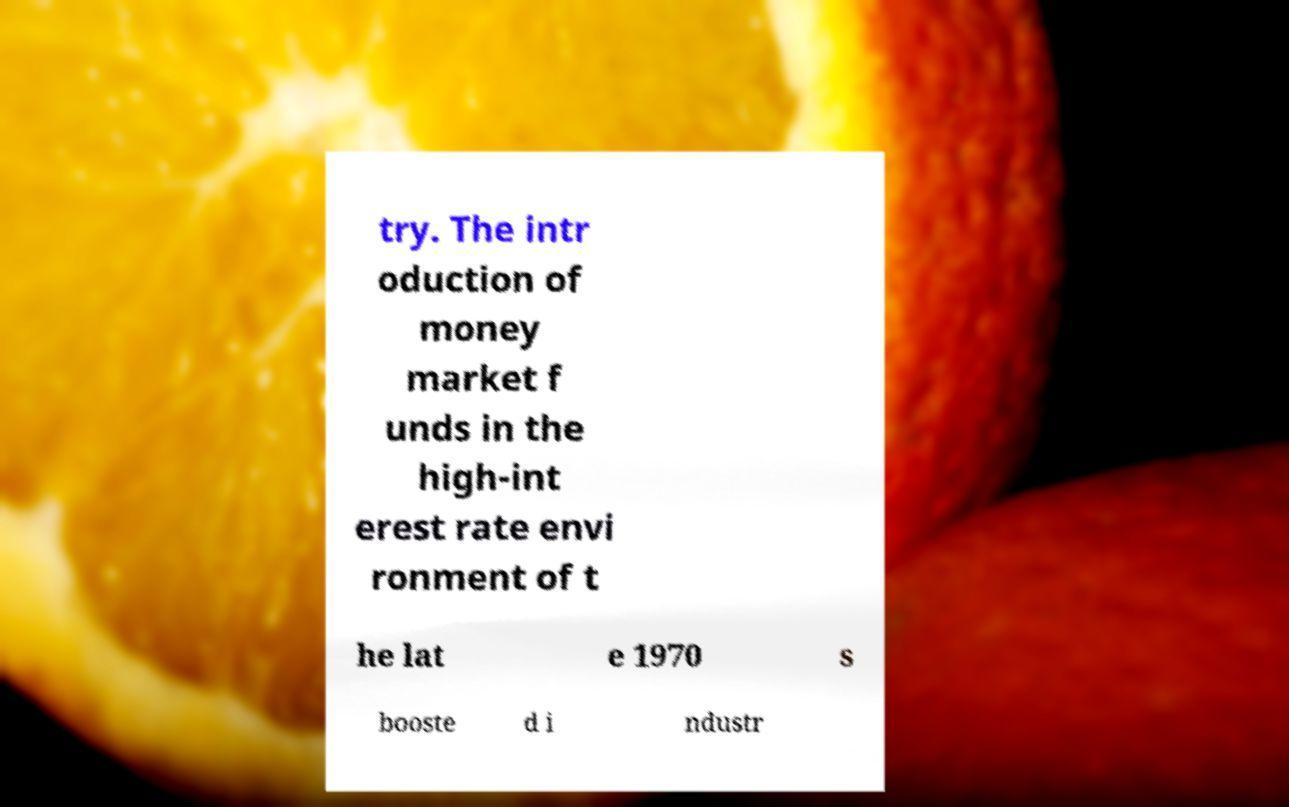Please read and relay the text visible in this image. What does it say? try. The intr oduction of money market f unds in the high-int erest rate envi ronment of t he lat e 1970 s booste d i ndustr 